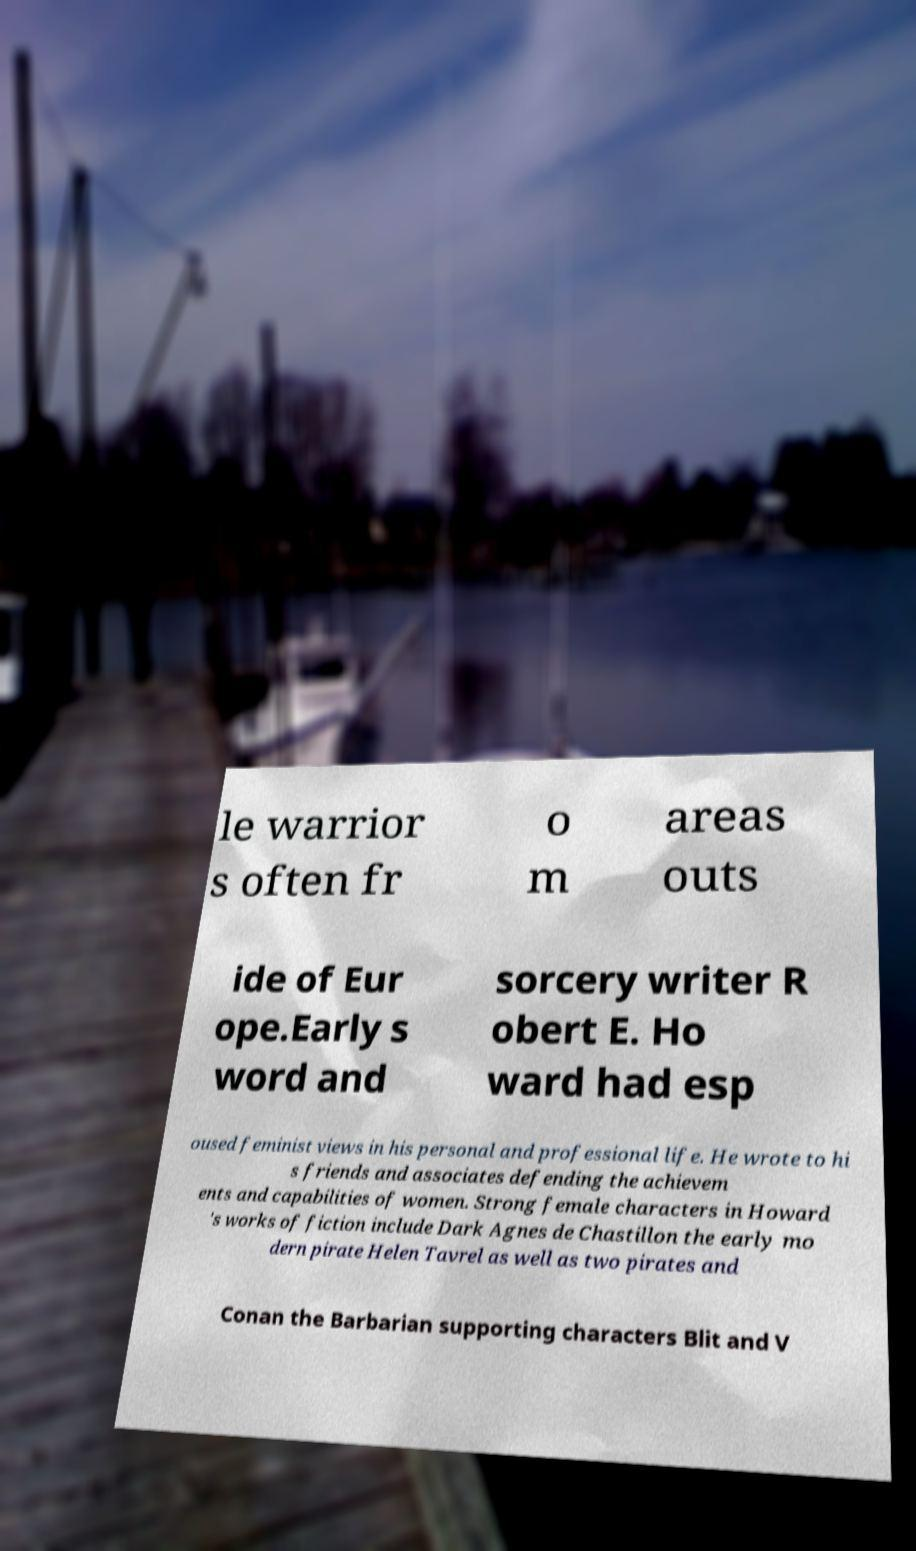Can you read and provide the text displayed in the image?This photo seems to have some interesting text. Can you extract and type it out for me? le warrior s often fr o m areas outs ide of Eur ope.Early s word and sorcery writer R obert E. Ho ward had esp oused feminist views in his personal and professional life. He wrote to hi s friends and associates defending the achievem ents and capabilities of women. Strong female characters in Howard 's works of fiction include Dark Agnes de Chastillon the early mo dern pirate Helen Tavrel as well as two pirates and Conan the Barbarian supporting characters Blit and V 